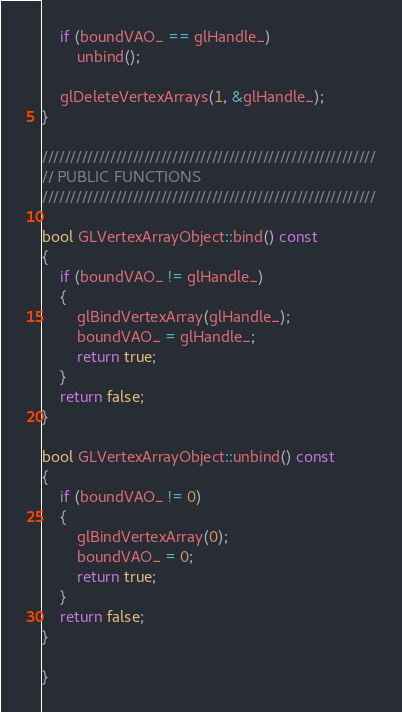<code> <loc_0><loc_0><loc_500><loc_500><_C++_>	if (boundVAO_ == glHandle_)
		unbind();

	glDeleteVertexArrays(1, &glHandle_);
}

///////////////////////////////////////////////////////////
// PUBLIC FUNCTIONS
///////////////////////////////////////////////////////////

bool GLVertexArrayObject::bind() const
{
	if (boundVAO_ != glHandle_)
	{
		glBindVertexArray(glHandle_);
		boundVAO_ = glHandle_;
		return true;
	}
	return false;
}

bool GLVertexArrayObject::unbind() const
{
	if (boundVAO_ != 0)
	{
		glBindVertexArray(0);
		boundVAO_ = 0;
		return true;
	}
	return false;
}

}
</code> 